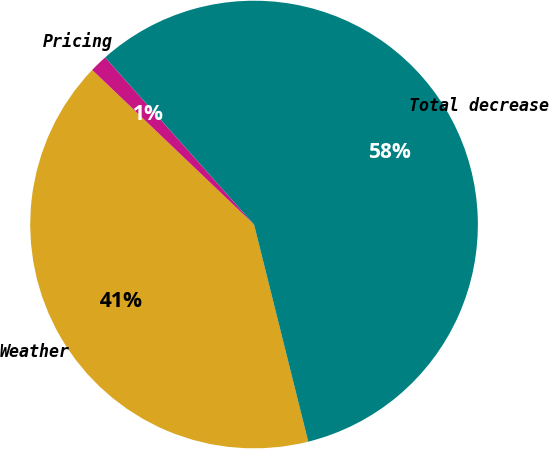<chart> <loc_0><loc_0><loc_500><loc_500><pie_chart><fcel>Weather<fcel>Pricing<fcel>Total decrease<nl><fcel>41.03%<fcel>1.28%<fcel>57.69%<nl></chart> 